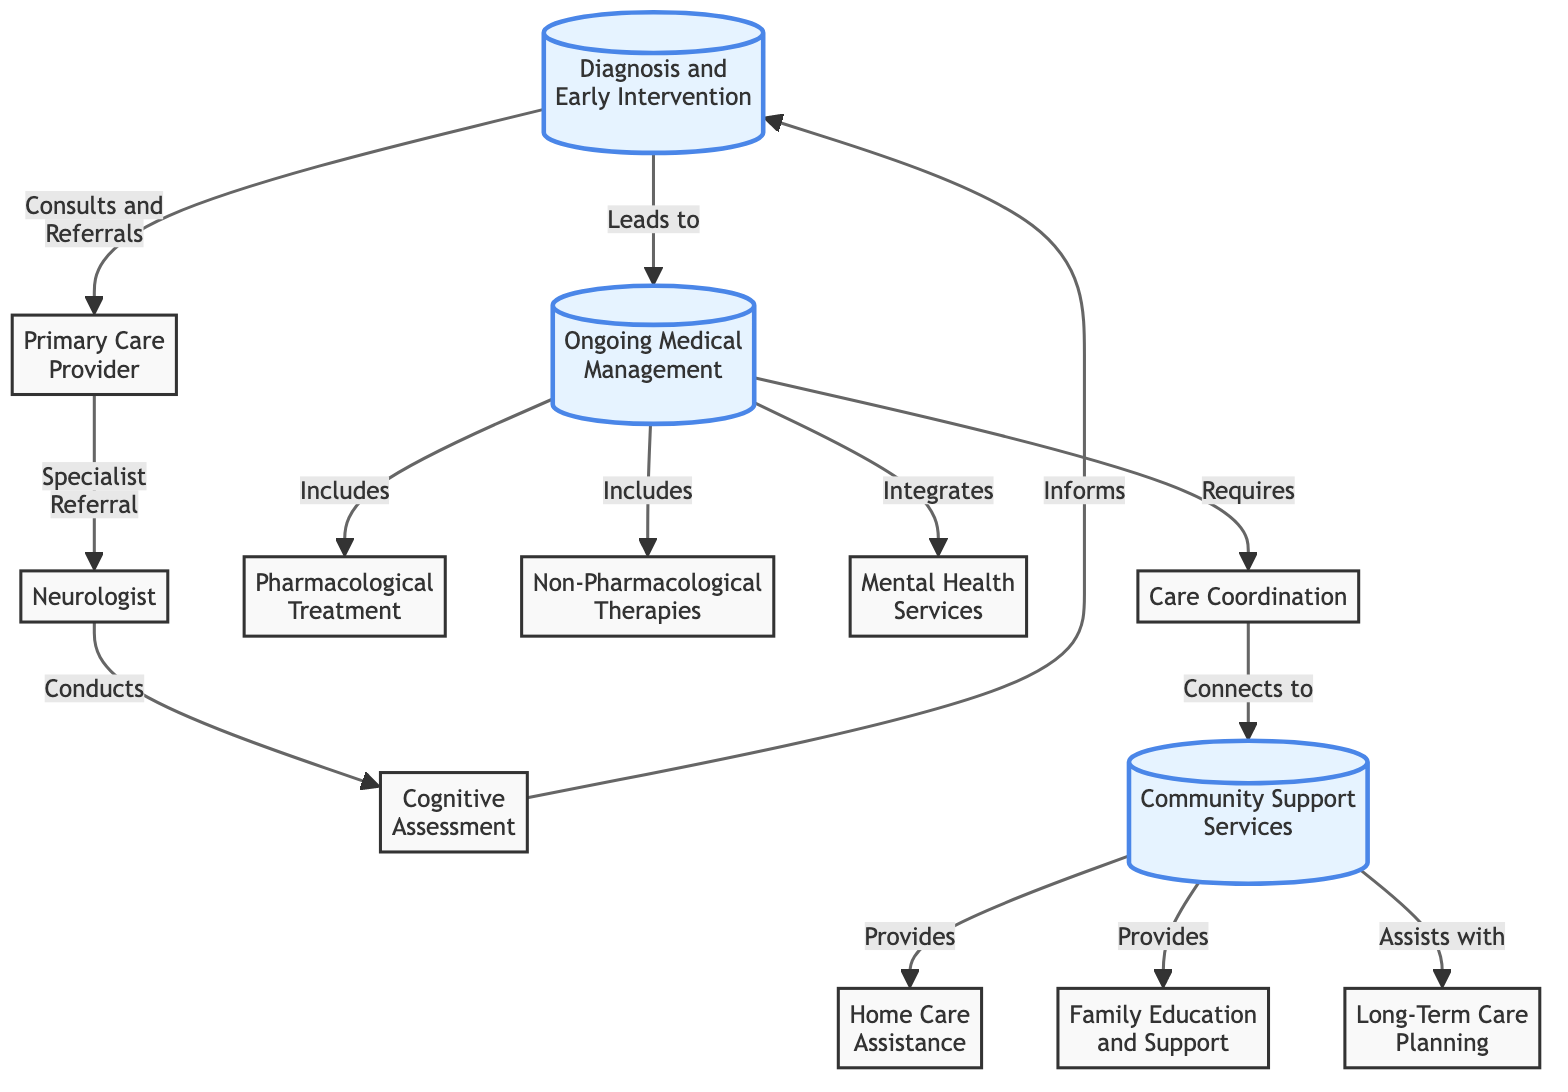What is the first step in the care pathway? The first step in the care pathway is represented by the node labelled "Diagnosis and Early Intervention." This node is depicted at the start of the flowchart, indicating it as the initial point in the care process.
Answer: Diagnosis and Early Intervention How many types of ongoing medical management are included? The ongoing medical management section includes three types: Pharmacological Treatment, Non-Pharmacological Therapies, and Mental Health Services. These are connected directly to the node labelled "Ongoing Medical Management," making it clear that there are three components.
Answer: 3 What does the ongoing medical management connect to? The "Ongoing Medical Management" node connects to the "Community Support Services" node. This relationship is indicated in the diagram, showing that ongoing medical management requires an integration with community support services.
Answer: Community Support Services Which service provides home care assistance? The service that provides home care assistance is indicated in the "Community Support Services" section, specifically marked as "Home Care Assistance." This connection shows its provision role within the larger context of support services for Alzheimer's patients.
Answer: Home Care Assistance What leads to the need for ongoing medical management? The arrow shows that the "Diagnosis and Early Intervention" leads directly to the need for "Ongoing Medical Management." By understanding the flow, it's clear that the diagnosis initiates the subsequent medical management requirements.
Answer: Ongoing Medical Management What connects to community support services regarding long-term care? The "Community Support Services" node assists with "Long-Term Care Planning." This relationship indicates that community support extends not only to immediate assistance but also to future care preparations for individuals with Alzheimer's disease.
Answer: Long-Term Care Planning 